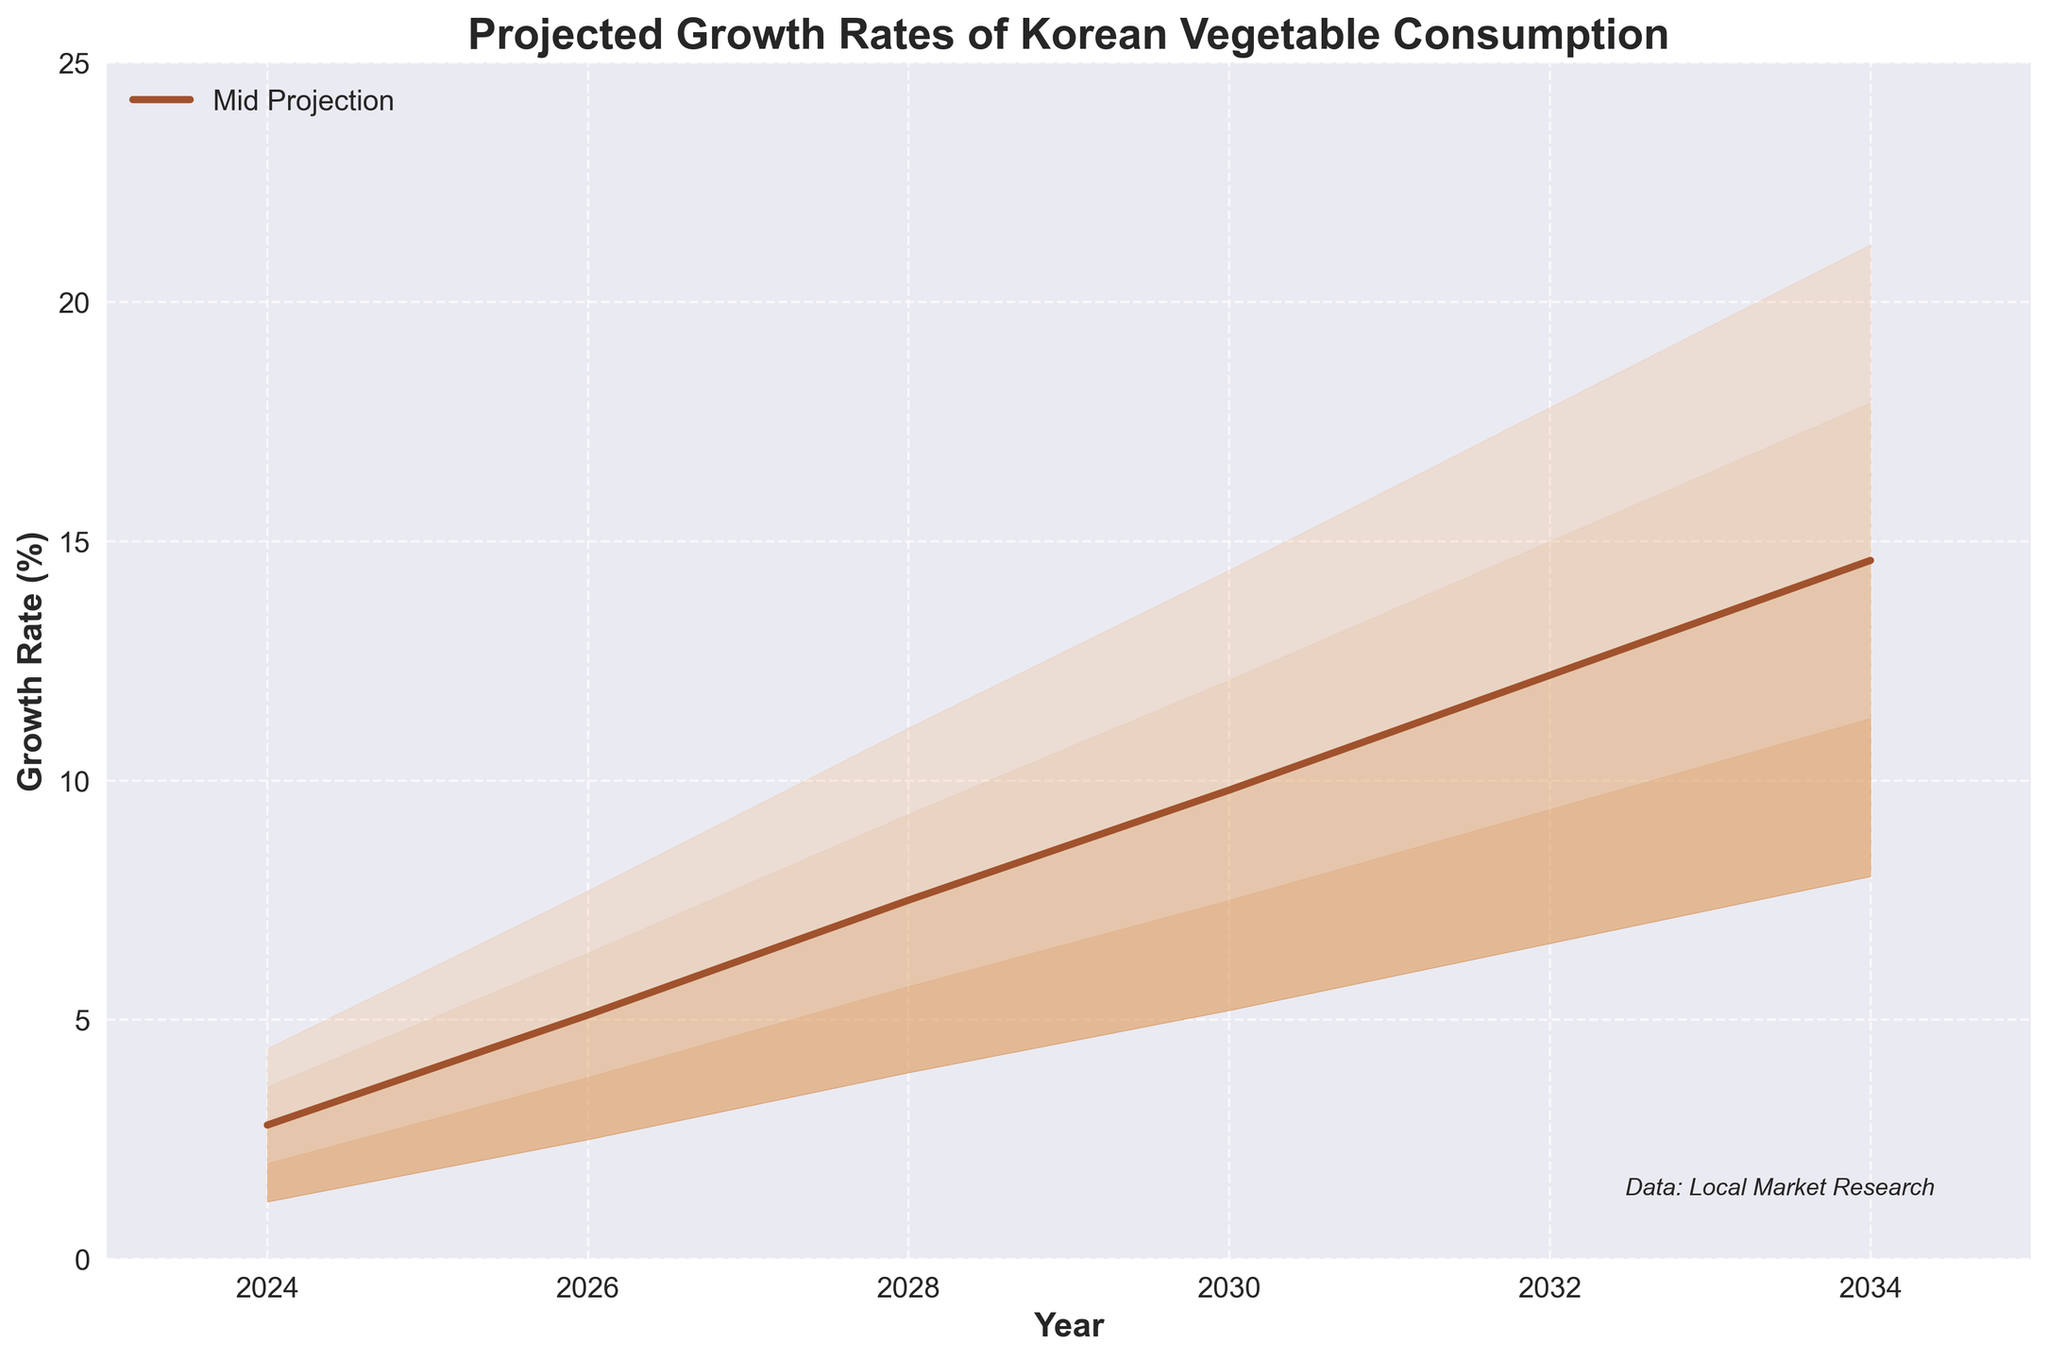What is the title of the chart? The title is displayed prominently at the top, where it reads "Projected Growth Rates of Korean Vegetable Consumption."
Answer: Projected Growth Rates of Korean Vegetable Consumption What's the range of years shown in the chart? The x-axis labels display the years from 2024 to 2034.
Answer: 2024 to 2034 How many growth rate projections are displayed for each year? The chart shows five different growth rate projections for each year, labeled as Low, Low-Mid, Mid, Mid-High, and High.
Answer: Five What is the projected mid growth rate of Korean vegetable consumption in 2030? Locate the value at the intersection of the "Mid" curve and the year 2030. The "Mid" growth rate value is 9.8%.
Answer: 9.8% In which year does the projected high growth rate reach approximately 21.2%? Locate the year corresponding to the "High" growth rate value of 21.2%. This value appears at 2034.
Answer: 2034 What is the difference between the mid and high projections in 2026? Find the mid and high values for 2026. The mid value is 5.1%, and the high value is 7.7%. The difference is 7.7 - 5.1 = 2.6%.
Answer: 2.6% Which color is used for the Mid-High growth rate projection, and why might this be helpful? Identify the color of the Mid-High projection area. It is colored light brown, which helps differentiate between different projections visually.
Answer: Light brown What is the average mid growth rate between 2024 and 2034? To find the average, sum the mid-growth rates for the years 2024 (2.8%), 2026 (5.1%), 2028 (7.5%), 2030 (9.8%), 2032 (12.2%), and 2034 (14.6%), then divide by 6. (2.8 + 5.1 + 7.5 + 9.8 + 12.2 + 14.6) / 6 = 8.67%
Answer: 8.67% How does the projected growth rate change from 2024 to 2034 for the lowest growth rate scenario? Identify the values for the "Low" growth rate in 2024 (1.2%) and 2034 (8.0%) and find the difference. The change is 8.0 - 1.2 = 6.8%.
Answer: 6.8% Which year shows the closest values between the Mid and Low-Mid projections? Compare the differences between Mid and Low-Mid values for all years. In 2024, the values are Mid = 2.8% and Low-Mid = 2.0%, giving a difference of 0.8%, which is the smallest difference among all years.
Answer: 2024 